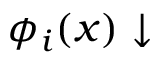Convert formula to latex. <formula><loc_0><loc_0><loc_500><loc_500>\phi _ { i } ( x ) \downarrow</formula> 